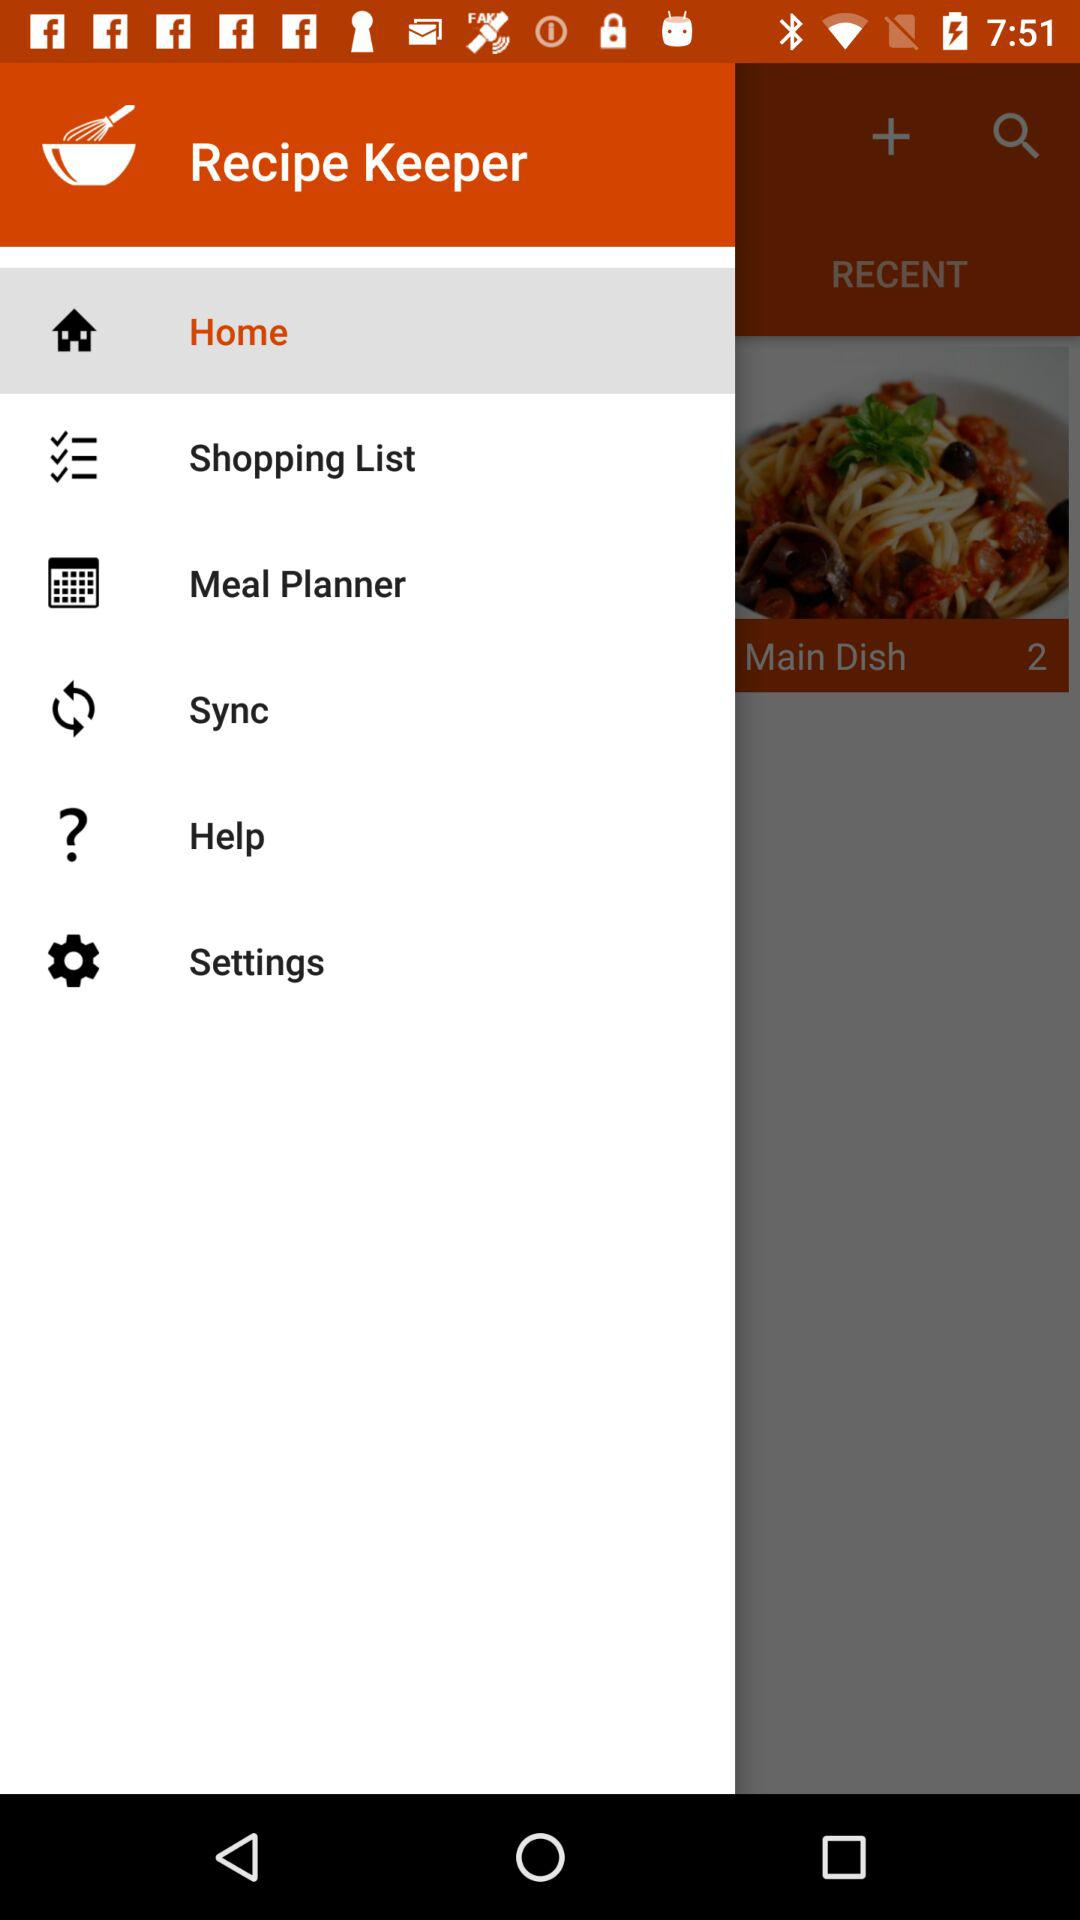What is the name of the application? The name of the application is "Recipe Keeper". 